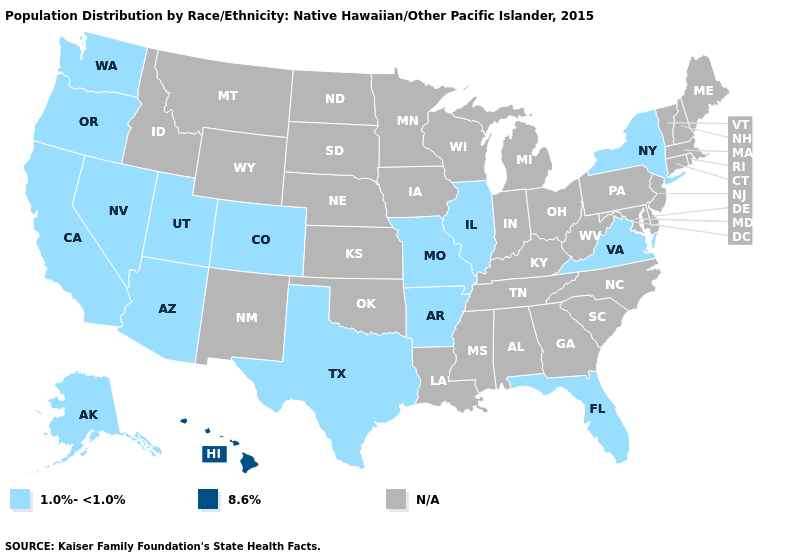What is the highest value in the MidWest ?
Answer briefly. 1.0%-<1.0%. Name the states that have a value in the range N/A?
Answer briefly. Alabama, Connecticut, Delaware, Georgia, Idaho, Indiana, Iowa, Kansas, Kentucky, Louisiana, Maine, Maryland, Massachusetts, Michigan, Minnesota, Mississippi, Montana, Nebraska, New Hampshire, New Jersey, New Mexico, North Carolina, North Dakota, Ohio, Oklahoma, Pennsylvania, Rhode Island, South Carolina, South Dakota, Tennessee, Vermont, West Virginia, Wisconsin, Wyoming. Which states have the lowest value in the South?
Answer briefly. Arkansas, Florida, Texas, Virginia. Which states hav the highest value in the MidWest?
Be succinct. Illinois, Missouri. Does the map have missing data?
Write a very short answer. Yes. Name the states that have a value in the range 1.0%-<1.0%?
Quick response, please. Alaska, Arizona, Arkansas, California, Colorado, Florida, Illinois, Missouri, Nevada, New York, Oregon, Texas, Utah, Virginia, Washington. What is the highest value in the USA?
Quick response, please. 8.6%. Name the states that have a value in the range 1.0%-<1.0%?
Quick response, please. Alaska, Arizona, Arkansas, California, Colorado, Florida, Illinois, Missouri, Nevada, New York, Oregon, Texas, Utah, Virginia, Washington. Does Hawaii have the lowest value in the USA?
Keep it brief. No. Among the states that border Arizona , which have the highest value?
Be succinct. California, Colorado, Nevada, Utah. 